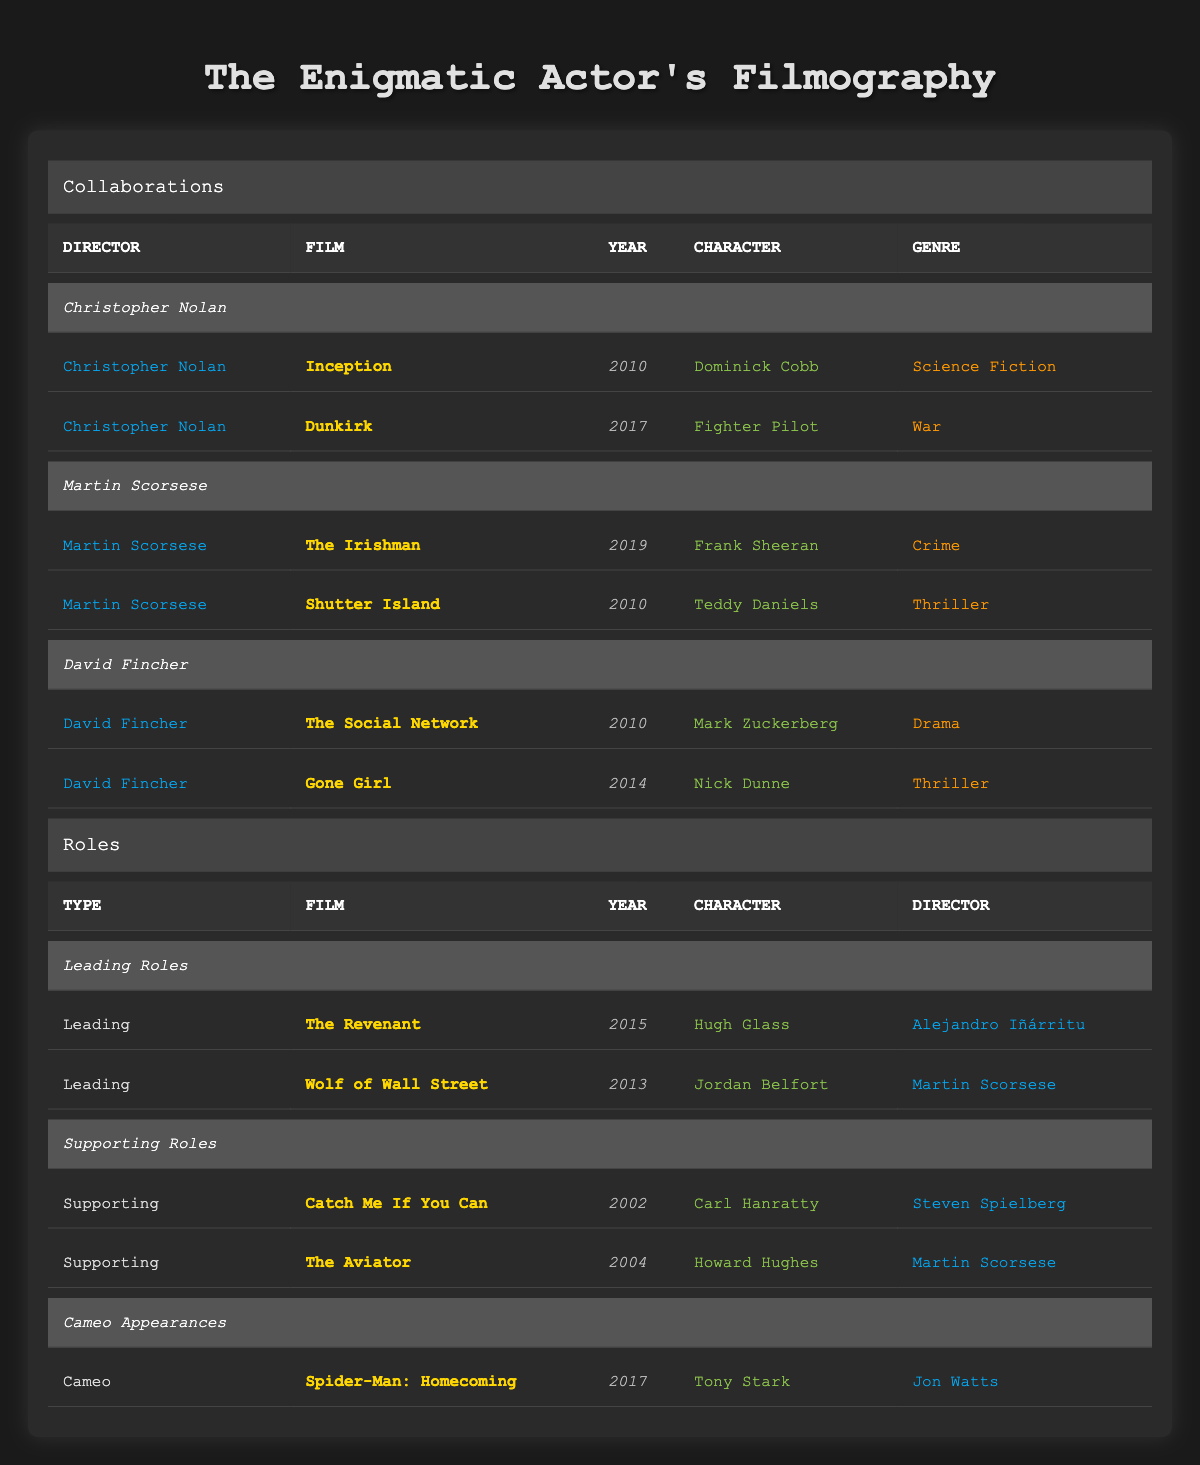What are the two films where you collaborated with Christopher Nolan? The table lists the films directed by Christopher Nolan along with the roles played in them. The films are "Inception" (2010) and "Dunkirk" (2017).
Answer: Inception, Dunkirk Which year did you portray the character Frank Sheeran? Referring to Martin Scorsese's filmography in the table, Frank Sheeran was portrayed in "The Irishman," which was released in 2019.
Answer: 2019 Did you have any roles in films directed by David Fincher? The table shows that there are two films with roles under David Fincher: "The Social Network" and "Gone Girl." This confirms that there were roles in films directed by David Fincher.
Answer: Yes How many films are categorized as Leading Roles in your filmography? Looking at the "Leading Roles" section of the table, there are two films listed: "The Revenant" and "Wolf of Wall Street."
Answer: 2 What genre is the film "The Aviator"? By consulting the row for "The Aviator," the genre listed is "Biography."
Answer: Biography Can you name the only film in which you made a cameo appearance? The table specifies a section for Cameo Appearances, which lists "Spider-Man: Homecoming" as the only film where a cameo was made.
Answer: Spider-Man: Homecoming In total, how many films have you worked on with Martin Scorsese? Analyzing the collaborations with Martin Scorsese, there are three films: "The Irishman," "Shutter Island," and "Wolf of Wall Street" (noting that "Wolf of Wall Street" appears in the Leading Roles). Adding these gives a total of three films.
Answer: 3 What was the character you played in "Gone Girl"? The table indicates that the character in "Gone Girl" is "Nick Dunne."
Answer: Nick Dunne How many different directors have you collaborated with in your filmography? The table lists three directors: Christopher Nolan, Martin Scorsese, and David Fincher. Counting these names gives a total of three different collaborations.
Answer: 3 